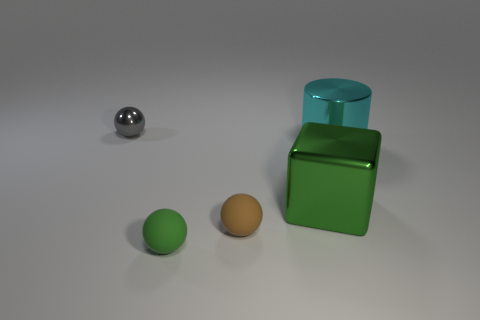What number of brown objects are matte objects or tiny shiny things?
Your answer should be compact. 1. Are there an equal number of cyan shiny cylinders that are in front of the cyan shiny object and cyan matte balls?
Give a very brief answer. Yes. How many things are either big yellow metal objects or objects that are behind the big metal cylinder?
Offer a terse response. 1. Does the cylinder have the same color as the big metallic block?
Give a very brief answer. No. Are there any other tiny brown balls that have the same material as the brown sphere?
Provide a succinct answer. No. What is the color of the other tiny shiny thing that is the same shape as the tiny brown object?
Your answer should be very brief. Gray. Do the big cyan cylinder and the object in front of the brown rubber sphere have the same material?
Provide a succinct answer. No. There is a big object that is left of the cylinder that is right of the big green metal object; what is its shape?
Give a very brief answer. Cube. Do the green thing that is on the left side of the green metal cube and the cylinder have the same size?
Ensure brevity in your answer.  No. How many other things are there of the same shape as the gray shiny object?
Keep it short and to the point. 2. 